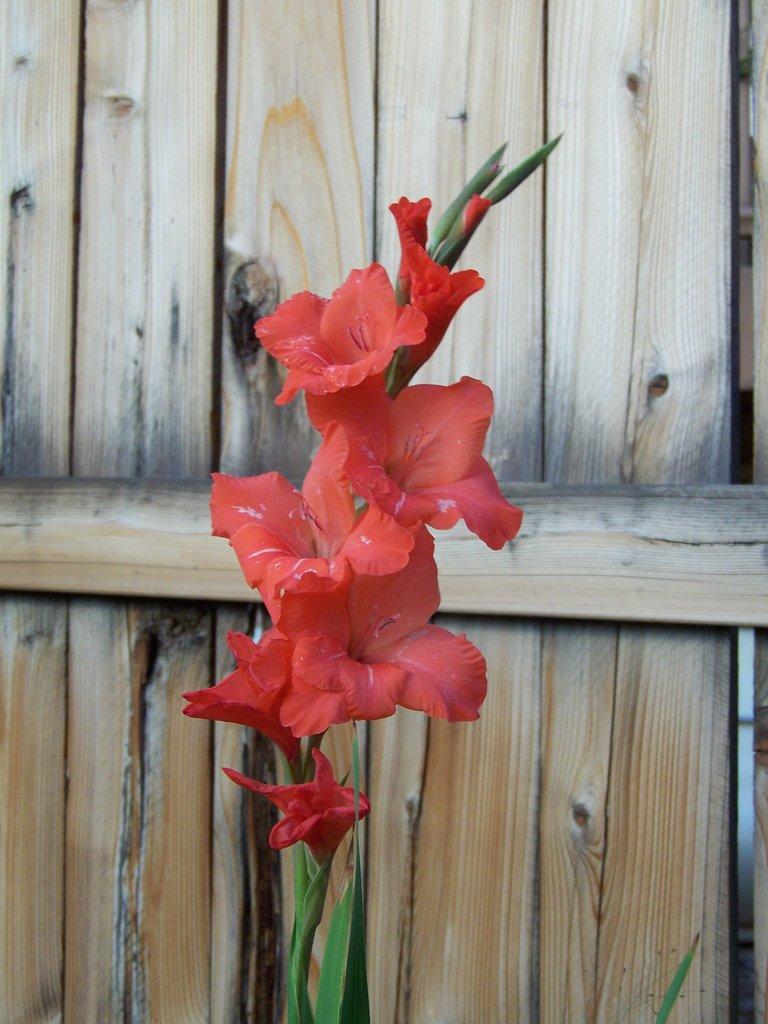How would you summarize this image in a sentence or two? This looks like a plant with a flowers, leaves and buds. These flowers are red in color. In the background, that looks like a wooden door. 